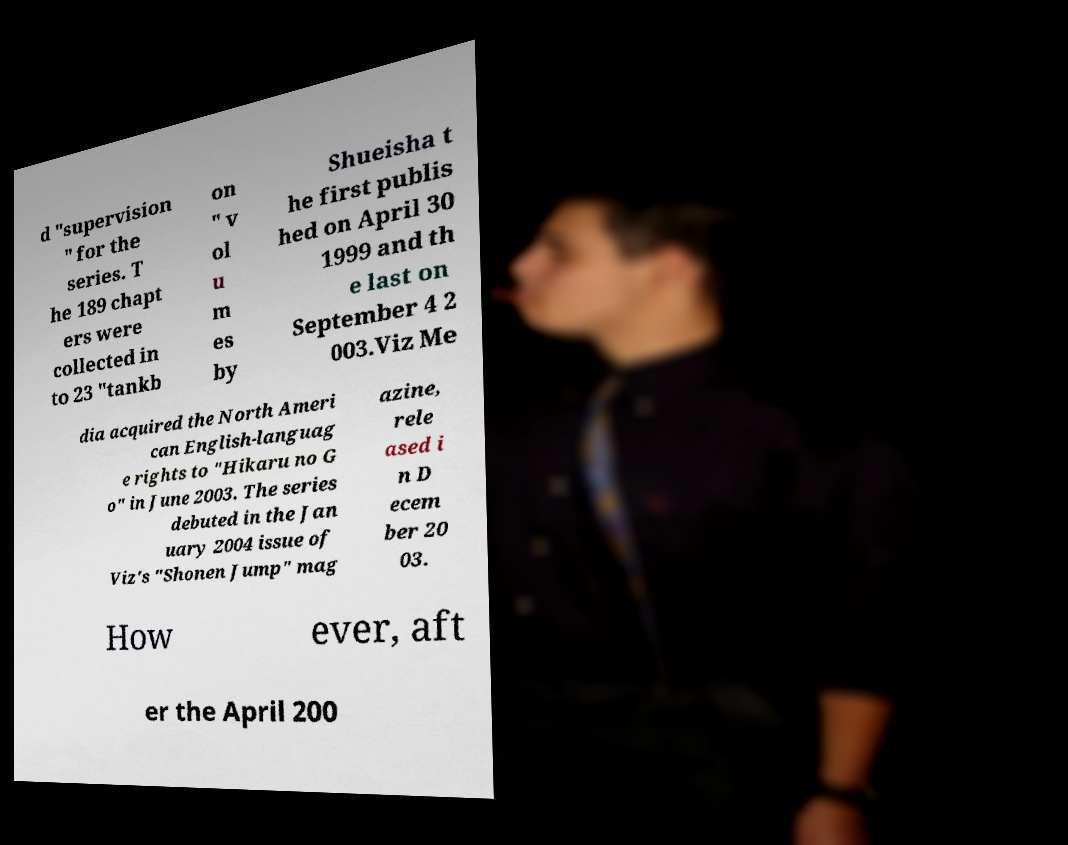Please read and relay the text visible in this image. What does it say? d "supervision " for the series. T he 189 chapt ers were collected in to 23 "tankb on " v ol u m es by Shueisha t he first publis hed on April 30 1999 and th e last on September 4 2 003.Viz Me dia acquired the North Ameri can English-languag e rights to "Hikaru no G o" in June 2003. The series debuted in the Jan uary 2004 issue of Viz's "Shonen Jump" mag azine, rele ased i n D ecem ber 20 03. How ever, aft er the April 200 